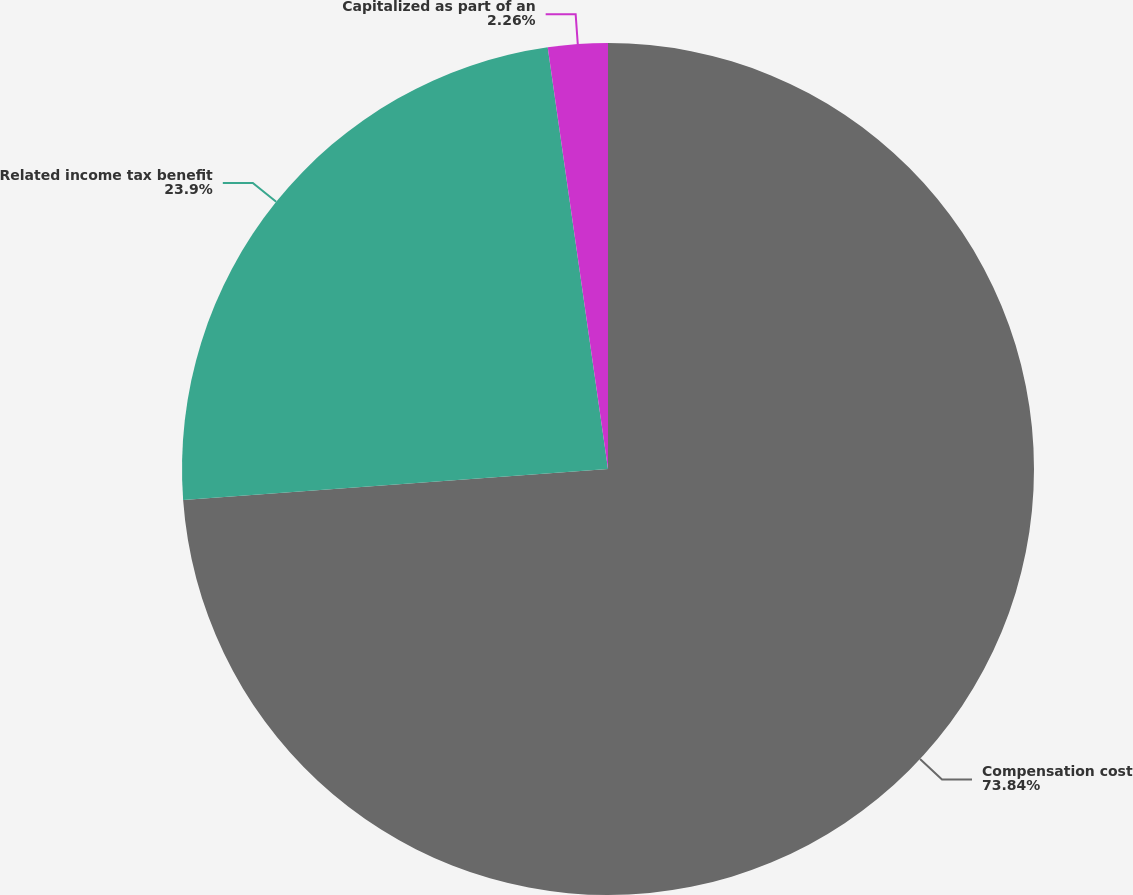<chart> <loc_0><loc_0><loc_500><loc_500><pie_chart><fcel>Compensation cost<fcel>Related income tax benefit<fcel>Capitalized as part of an<nl><fcel>73.83%<fcel>23.9%<fcel>2.26%<nl></chart> 